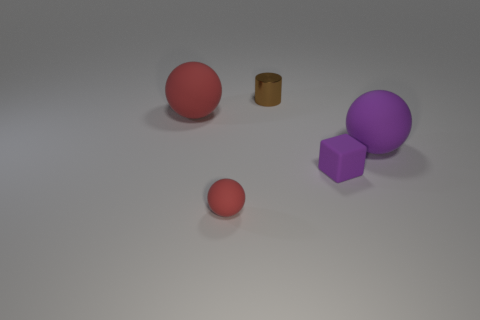Add 5 blocks. How many objects exist? 10 Subtract all cubes. How many objects are left? 4 Add 1 big purple matte spheres. How many big purple matte spheres are left? 2 Add 4 red matte things. How many red matte things exist? 6 Subtract 2 red balls. How many objects are left? 3 Subtract all small metal things. Subtract all small brown cylinders. How many objects are left? 3 